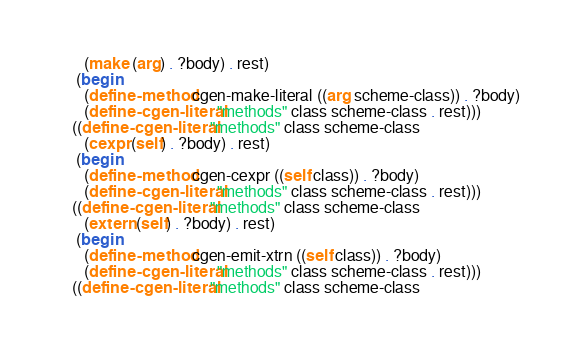Convert code to text. <code><loc_0><loc_0><loc_500><loc_500><_Scheme_>       (make (arg) . ?body) . rest)
     (begin
       (define-method cgen-make-literal ((arg scheme-class)) . ?body)
       (define-cgen-literal "methods" class scheme-class . rest)))
    ((define-cgen-literal "methods" class scheme-class
       (cexpr (self) . ?body) . rest)
     (begin
       (define-method cgen-cexpr ((self class)) . ?body)
       (define-cgen-literal "methods" class scheme-class . rest)))
    ((define-cgen-literal "methods" class scheme-class
       (extern (self) . ?body) . rest)
     (begin
       (define-method cgen-emit-xtrn ((self class)) . ?body)
       (define-cgen-literal "methods" class scheme-class . rest)))
    ((define-cgen-literal "methods" class scheme-class</code> 